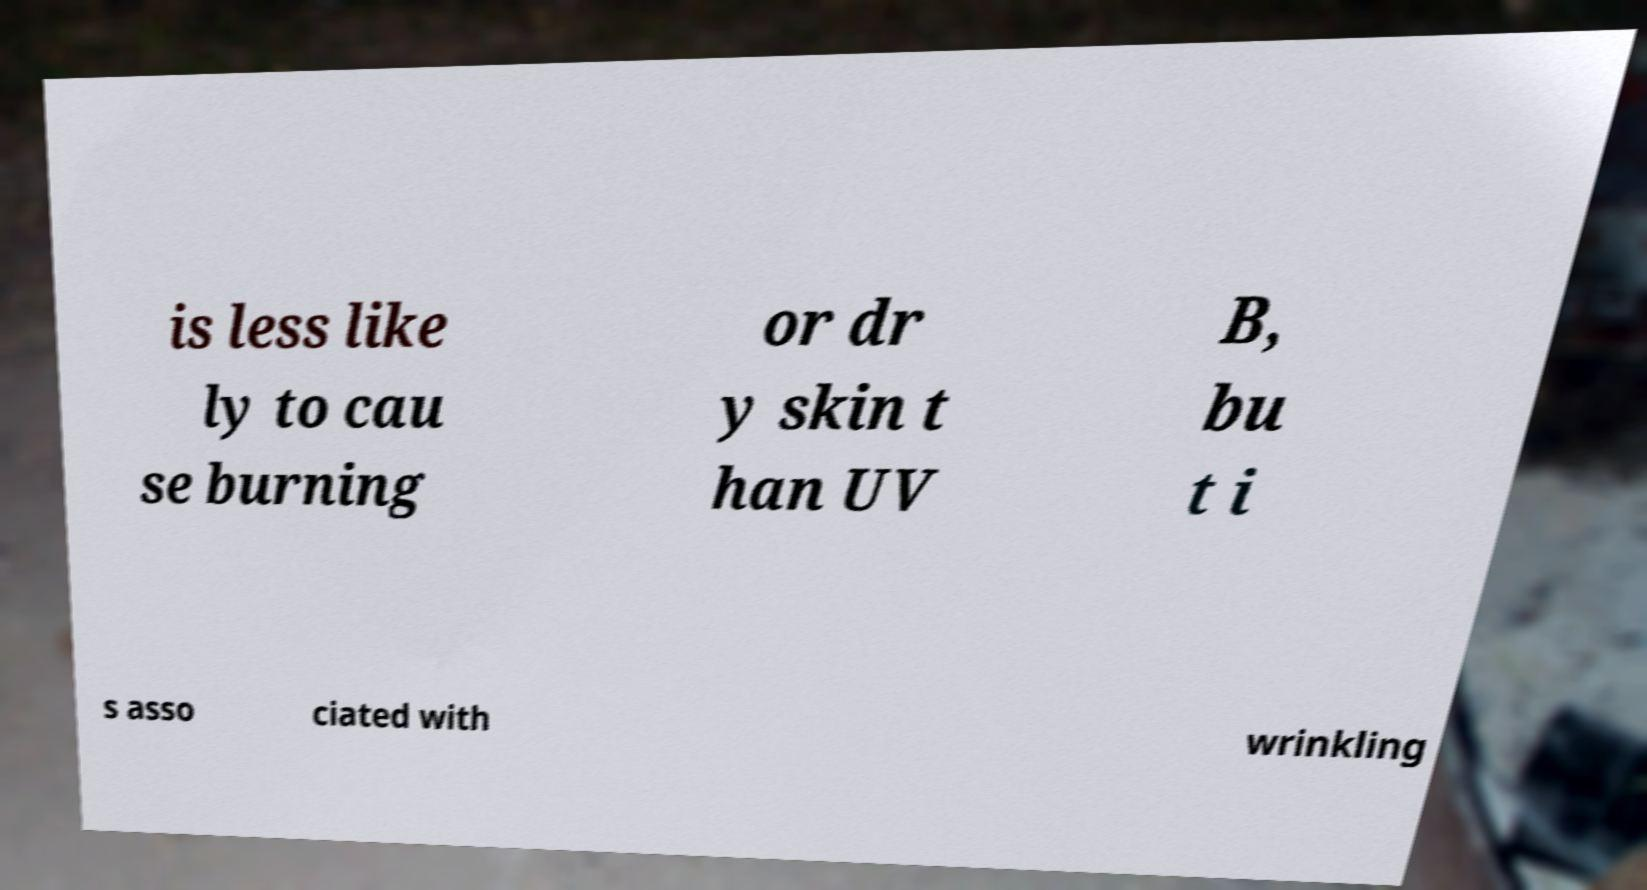I need the written content from this picture converted into text. Can you do that? is less like ly to cau se burning or dr y skin t han UV B, bu t i s asso ciated with wrinkling 